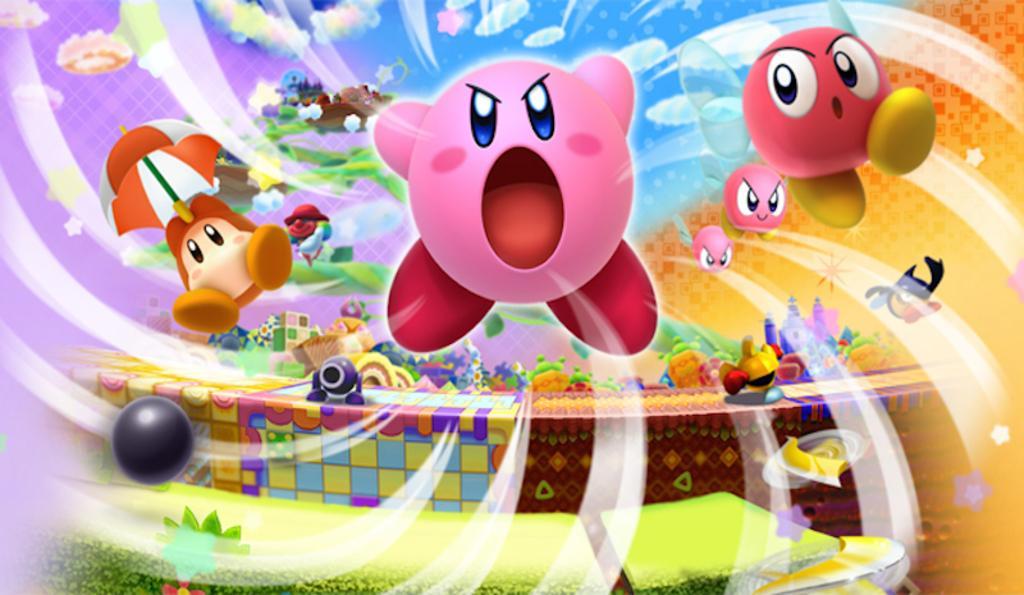Can you describe this image briefly? In this picture we can see toys, umbrella, sky with clouds, ball and some objects. 